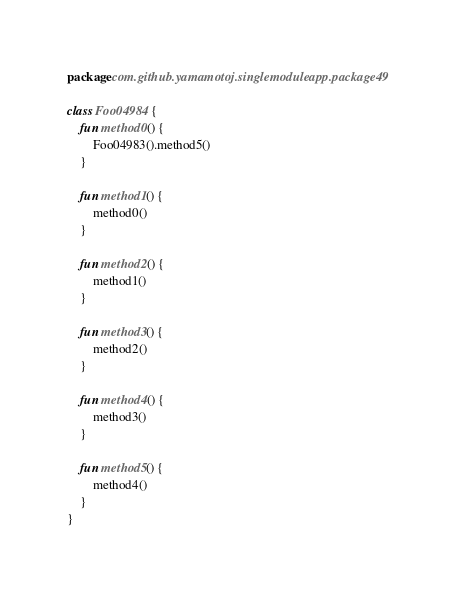Convert code to text. <code><loc_0><loc_0><loc_500><loc_500><_Kotlin_>package com.github.yamamotoj.singlemoduleapp.package49

class Foo04984 {
    fun method0() {
        Foo04983().method5()
    }

    fun method1() {
        method0()
    }

    fun method2() {
        method1()
    }

    fun method3() {
        method2()
    }

    fun method4() {
        method3()
    }

    fun method5() {
        method4()
    }
}
</code> 